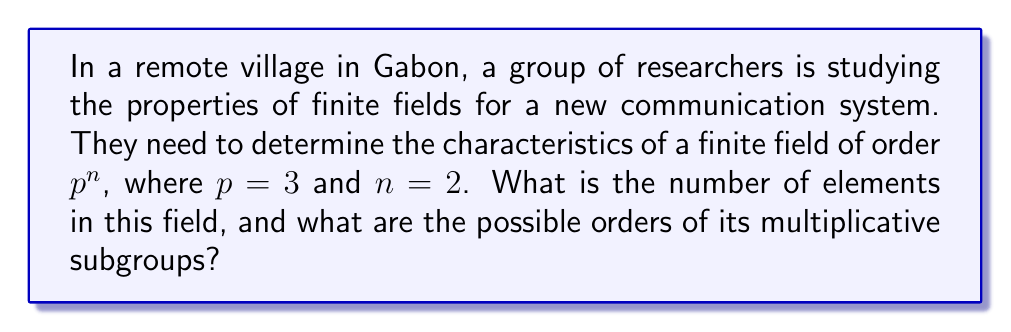Show me your answer to this math problem. Let's approach this step-by-step:

1) The order of the finite field:
   - The field has order $p^n = 3^2 = 9$ elements.

2) The elements of the field:
   - The elements are $\{0, 1, 2, x, x+1, x+2, 2x, 2x+1, 2x+2\}$, where $x$ is a root of an irreducible polynomial of degree 2 over $\mathbb{F}_3$.

3) The multiplicative group:
   - The multiplicative group of the field, $\mathbb{F}_9^*$, consists of all non-zero elements.
   - It has $9 - 1 = 8$ elements.

4) Order of the multiplicative group:
   - The order of $\mathbb{F}_9^*$ is 8.

5) Possible orders of multiplicative subgroups:
   - By Lagrange's theorem, the order of any subgroup must divide the order of the group.
   - The divisors of 8 are 1, 2, 4, and 8.

Therefore, the possible orders of multiplicative subgroups are 1, 2, 4, and 8.
Answer: 9 elements; subgroup orders: 1, 2, 4, 8 